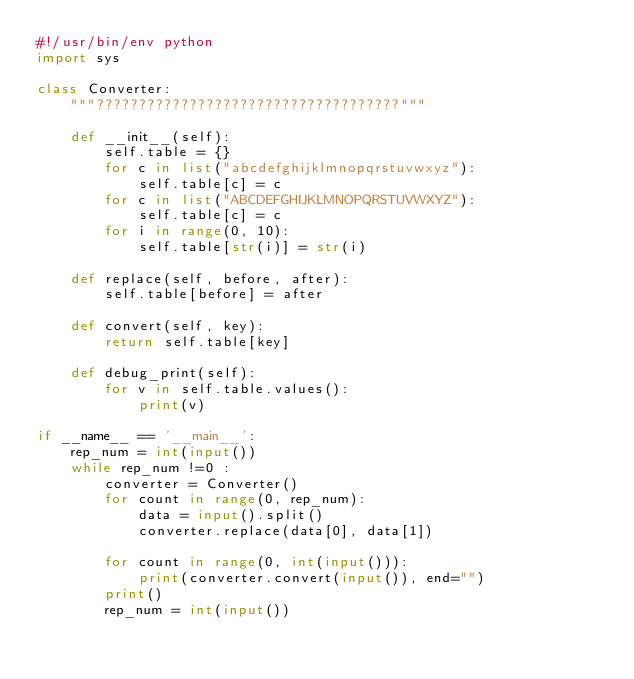Convert code to text. <code><loc_0><loc_0><loc_500><loc_500><_Python_>#!/usr/bin/env python
import sys

class Converter:
    """????????????????????????????????????"""

    def __init__(self):
        self.table = {}
        for c in list("abcdefghijklmnopqrstuvwxyz"):
            self.table[c] = c
        for c in list("ABCDEFGHIJKLMNOPQRSTUVWXYZ"):
            self.table[c] = c
        for i in range(0, 10):
            self.table[str(i)] = str(i)

    def replace(self, before, after):
        self.table[before] = after

    def convert(self, key):
        return self.table[key]

    def debug_print(self):
        for v in self.table.values():
            print(v)

if __name__ == '__main__':
    rep_num = int(input())
    while rep_num !=0 :
        converter = Converter()
        for count in range(0, rep_num):
            data = input().split()
            converter.replace(data[0], data[1])

        for count in range(0, int(input())):
            print(converter.convert(input()), end="")
        print()
        rep_num = int(input())</code> 